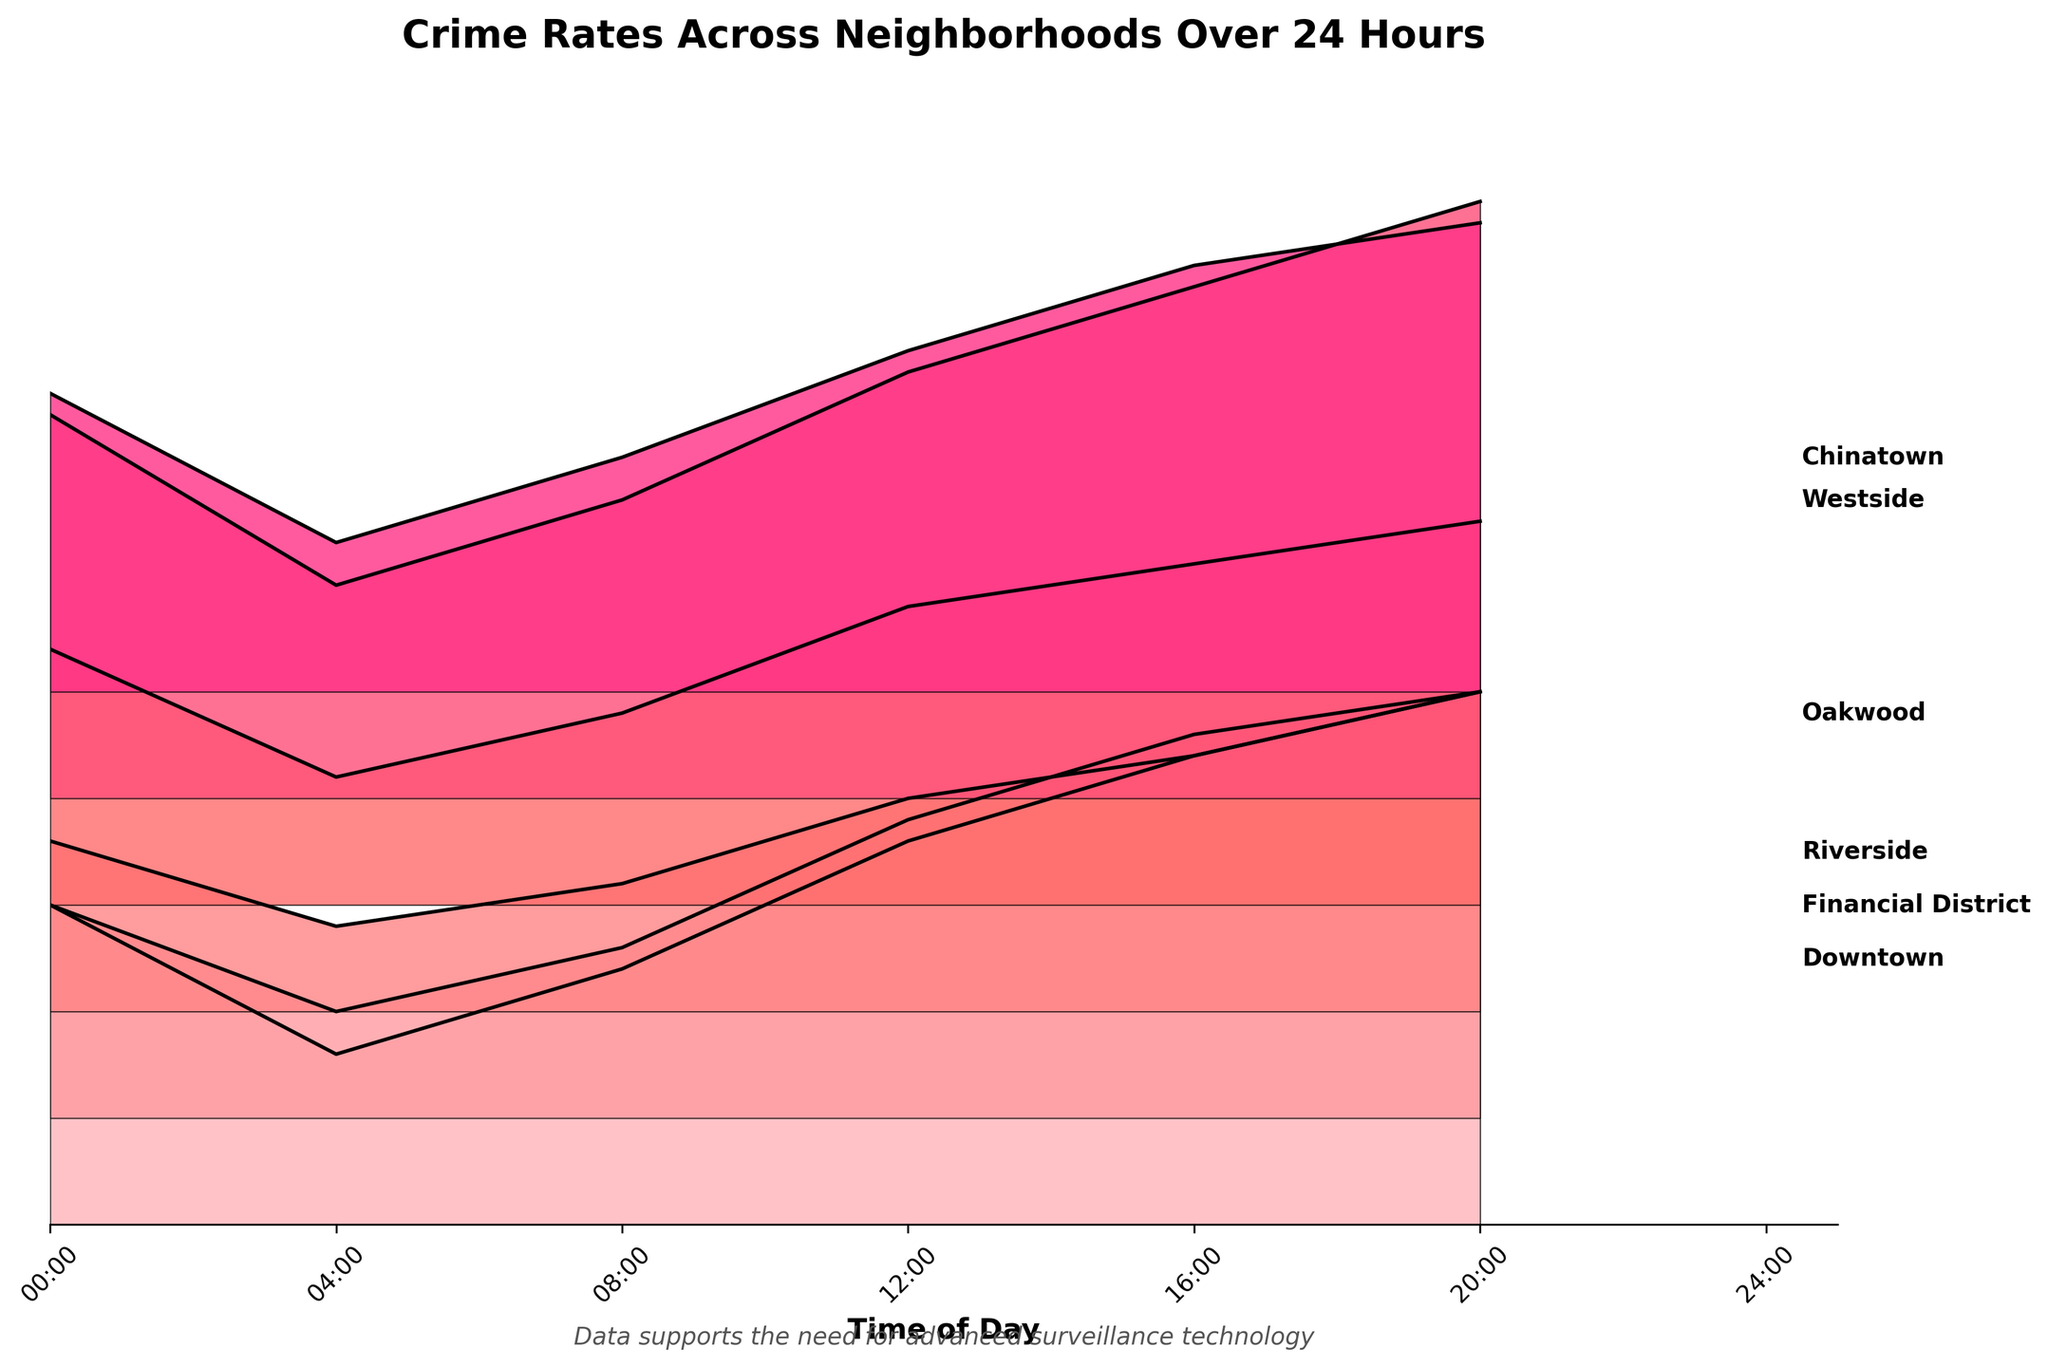What's the title of the plot? The title of the plot is written at the top in bold and larger font size.
Answer: Crime Rates Across Neighborhoods Over 24 Hours Which neighborhood has the highest crime rate at 8 PM? Among the ridgelines at 8 PM (hour 20), the Westside neighborhood has the highest peak.
Answer: Westside How often do crime rates peak in Downtown by the hour? Observing the peaks in Downtown, we see significant peaks at 12 PM and 8 PM.
Answer: Twice Which neighborhood has the lowest crime rate at midnight? At the 12 AM mark (hour 0), the Financial District has the lowest crime rate, which is 10.
Answer: Financial District During which hour is the crime rate highest in Riverside? The highest peak in Riverside is at 8 PM (hour 20), reaching 15.
Answer: 8 PM Compare the crime rate at noon between Downtown and Oakwood. Which one is higher? At 12 PM, Downtown has a peak at 18, while Oakwood has a peak at 14, indicating that Downtown's crime rate is higher.
Answer: Downtown What is the average crime rate for the financial district throughout the 24-hour period? The Financial District's crime rates at 0, 4, 8, 12, 16, and 20 hours are 10, 5, 8, 14, 18, and 20 respectively. Summing these gives 75, and dividing by 6 gives an average of 12.5.
Answer: 12.5 Which neighborhood shows an increase in crime rate at each recorded time? Observing the ridgelines, Westside's crime rate consistently rises at each recorded time interval.
Answer: Westside Between Chinatown and Oakwood, which neighborhood has the larger range in crime rates? The range is calculated as the difference between the highest and lowest points. Chinatown ranges from 7 to 22 (15) and Oakwood ranges from 6 to 18 (12), making Chinatown's range larger.
Answer: Chinatown Is there any neighborhood where crime rates are relatively stable across the day? Riverside exhibits the least variation, with crime rates ranging modestly between 4 and 15 throughout the day.
Answer: Riverside 